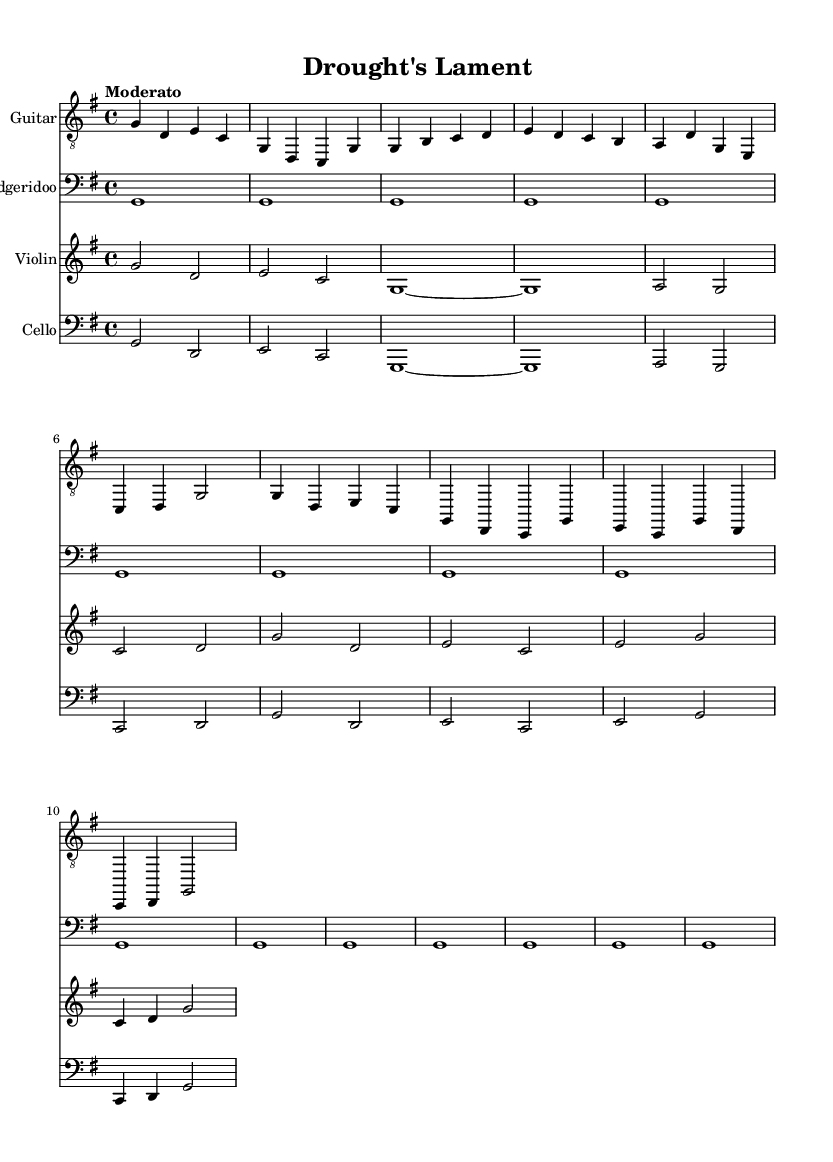What is the title of this music? The title is located at the top of the sheet music, prominently displayed in the header section. It reads "Drought's Lament."
Answer: Drought's Lament What is the key signature of this music? The key signature is indicated at the beginning of the music. In this case, it is G major, which has one sharp.
Answer: G major What is the time signature of this music? The time signature is noted alongside the key signature, represented as a fraction. Here, it is 4/4, which means there are four beats in each measure.
Answer: 4/4 What is the tempo marking of this music? The tempo marking is indicated in the score as "Moderato," which indicates a moderate speed of the music.
Answer: Moderato How many measures does the verse section contain? The verse section consists of two staves of music, which includes two sets of four measures each. Therefore, it has a total of eight measures for the verse.
Answer: 8 Which instruments are used in this score? The instruments are listed in the staff headers at the beginning of each line, which includes Guitar, Didgeridoo, Violin, and Cello.
Answer: Guitar, Didgeridoo, Violin, Cello What musical elements are repeated in the Didgeridoo section? In the Didgeridoo section, the repeating note G is sustained throughout the entire section, demonstrating its drone-like quality.
Answer: G 